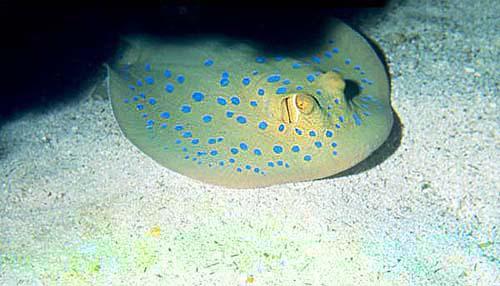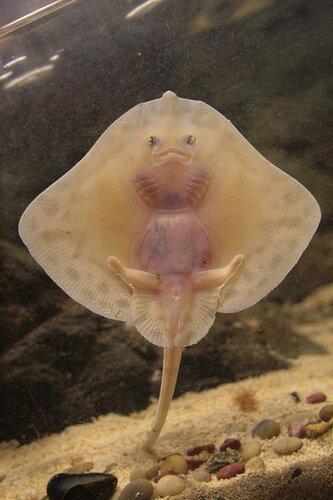The first image is the image on the left, the second image is the image on the right. Analyze the images presented: Is the assertion "The tail of the animal in the image on the left touches the left side of the image." valid? Answer yes or no. No. The first image is the image on the left, the second image is the image on the right. For the images shown, is this caption "An image shows a round-shaped stingray with an all-over pattern of distinctive spots." true? Answer yes or no. Yes. 